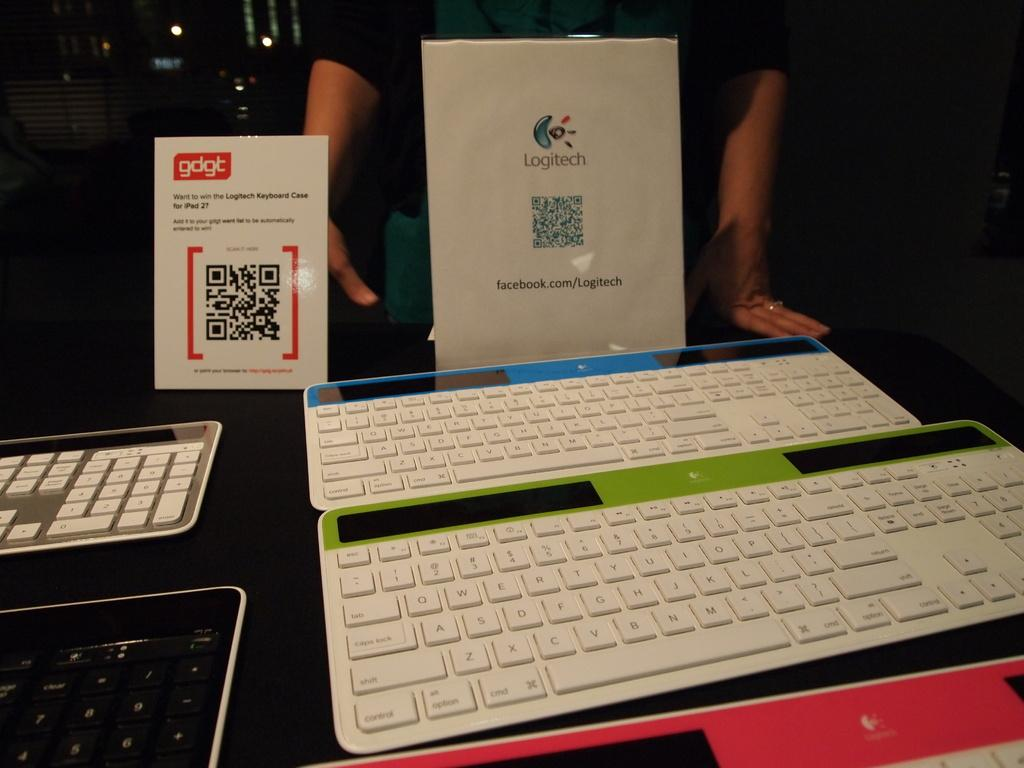<image>
Render a clear and concise summary of the photo. A display of white Logitech Keyboards with a facebook link. 